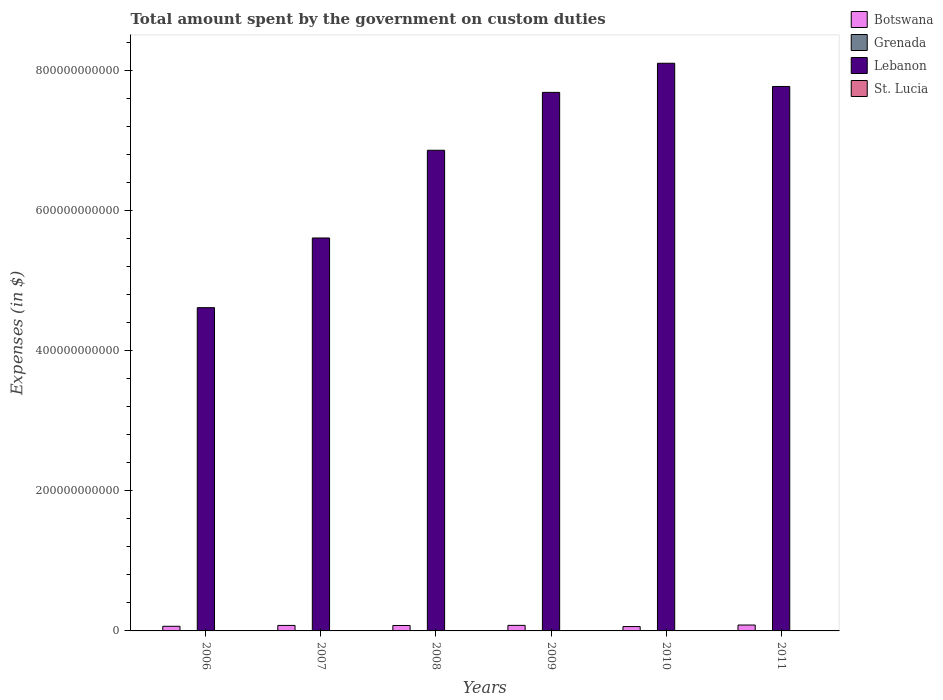How many groups of bars are there?
Your answer should be very brief. 6. Are the number of bars on each tick of the X-axis equal?
Your response must be concise. Yes. In how many cases, is the number of bars for a given year not equal to the number of legend labels?
Your answer should be very brief. 0. What is the amount spent on custom duties by the government in St. Lucia in 2008?
Offer a very short reply. 1.75e+08. Across all years, what is the maximum amount spent on custom duties by the government in Botswana?
Give a very brief answer. 8.42e+09. Across all years, what is the minimum amount spent on custom duties by the government in Botswana?
Your answer should be compact. 6.21e+09. In which year was the amount spent on custom duties by the government in Lebanon maximum?
Provide a short and direct response. 2010. What is the total amount spent on custom duties by the government in Lebanon in the graph?
Your response must be concise. 4.06e+12. What is the difference between the amount spent on custom duties by the government in Lebanon in 2008 and the amount spent on custom duties by the government in St. Lucia in 2009?
Give a very brief answer. 6.86e+11. What is the average amount spent on custom duties by the government in Botswana per year?
Offer a terse response. 7.46e+09. In the year 2009, what is the difference between the amount spent on custom duties by the government in Grenada and amount spent on custom duties by the government in Botswana?
Ensure brevity in your answer.  -7.85e+09. What is the ratio of the amount spent on custom duties by the government in Grenada in 2006 to that in 2010?
Your response must be concise. 1.07. Is the amount spent on custom duties by the government in Lebanon in 2009 less than that in 2010?
Offer a very short reply. Yes. What is the difference between the highest and the second highest amount spent on custom duties by the government in Grenada?
Offer a terse response. 9.00e+06. What is the difference between the highest and the lowest amount spent on custom duties by the government in Lebanon?
Your response must be concise. 3.49e+11. In how many years, is the amount spent on custom duties by the government in Grenada greater than the average amount spent on custom duties by the government in Grenada taken over all years?
Make the answer very short. 2. Is it the case that in every year, the sum of the amount spent on custom duties by the government in Lebanon and amount spent on custom duties by the government in Botswana is greater than the sum of amount spent on custom duties by the government in Grenada and amount spent on custom duties by the government in St. Lucia?
Provide a short and direct response. Yes. What does the 4th bar from the left in 2007 represents?
Give a very brief answer. St. Lucia. What does the 2nd bar from the right in 2011 represents?
Provide a succinct answer. Lebanon. Is it the case that in every year, the sum of the amount spent on custom duties by the government in Grenada and amount spent on custom duties by the government in Botswana is greater than the amount spent on custom duties by the government in St. Lucia?
Your answer should be very brief. Yes. What is the difference between two consecutive major ticks on the Y-axis?
Keep it short and to the point. 2.00e+11. Are the values on the major ticks of Y-axis written in scientific E-notation?
Offer a very short reply. No. Does the graph contain any zero values?
Offer a terse response. No. What is the title of the graph?
Offer a very short reply. Total amount spent by the government on custom duties. Does "Barbados" appear as one of the legend labels in the graph?
Make the answer very short. No. What is the label or title of the X-axis?
Give a very brief answer. Years. What is the label or title of the Y-axis?
Provide a short and direct response. Expenses (in $). What is the Expenses (in $) in Botswana in 2006?
Ensure brevity in your answer.  6.61e+09. What is the Expenses (in $) in Grenada in 2006?
Offer a very short reply. 8.74e+07. What is the Expenses (in $) in Lebanon in 2006?
Give a very brief answer. 4.61e+11. What is the Expenses (in $) of St. Lucia in 2006?
Your answer should be compact. 1.60e+08. What is the Expenses (in $) of Botswana in 2007?
Provide a short and direct response. 7.83e+09. What is the Expenses (in $) in Grenada in 2007?
Provide a succinct answer. 9.11e+07. What is the Expenses (in $) of Lebanon in 2007?
Provide a succinct answer. 5.61e+11. What is the Expenses (in $) in St. Lucia in 2007?
Provide a succinct answer. 1.72e+08. What is the Expenses (in $) in Botswana in 2008?
Offer a very short reply. 7.75e+09. What is the Expenses (in $) in Grenada in 2008?
Offer a very short reply. 1.00e+08. What is the Expenses (in $) in Lebanon in 2008?
Your answer should be very brief. 6.86e+11. What is the Expenses (in $) in St. Lucia in 2008?
Provide a succinct answer. 1.75e+08. What is the Expenses (in $) in Botswana in 2009?
Your answer should be very brief. 7.93e+09. What is the Expenses (in $) in Grenada in 2009?
Ensure brevity in your answer.  7.77e+07. What is the Expenses (in $) of Lebanon in 2009?
Offer a very short reply. 7.68e+11. What is the Expenses (in $) of St. Lucia in 2009?
Provide a short and direct response. 1.55e+08. What is the Expenses (in $) of Botswana in 2010?
Your answer should be very brief. 6.21e+09. What is the Expenses (in $) of Grenada in 2010?
Make the answer very short. 8.15e+07. What is the Expenses (in $) of Lebanon in 2010?
Offer a terse response. 8.10e+11. What is the Expenses (in $) of St. Lucia in 2010?
Give a very brief answer. 1.61e+08. What is the Expenses (in $) of Botswana in 2011?
Give a very brief answer. 8.42e+09. What is the Expenses (in $) of Grenada in 2011?
Provide a succinct answer. 8.71e+07. What is the Expenses (in $) of Lebanon in 2011?
Your response must be concise. 7.77e+11. What is the Expenses (in $) in St. Lucia in 2011?
Offer a very short reply. 1.75e+08. Across all years, what is the maximum Expenses (in $) of Botswana?
Keep it short and to the point. 8.42e+09. Across all years, what is the maximum Expenses (in $) of Grenada?
Offer a terse response. 1.00e+08. Across all years, what is the maximum Expenses (in $) of Lebanon?
Offer a very short reply. 8.10e+11. Across all years, what is the maximum Expenses (in $) in St. Lucia?
Your response must be concise. 1.75e+08. Across all years, what is the minimum Expenses (in $) of Botswana?
Give a very brief answer. 6.21e+09. Across all years, what is the minimum Expenses (in $) in Grenada?
Your answer should be compact. 7.77e+07. Across all years, what is the minimum Expenses (in $) in Lebanon?
Offer a terse response. 4.61e+11. Across all years, what is the minimum Expenses (in $) in St. Lucia?
Make the answer very short. 1.55e+08. What is the total Expenses (in $) in Botswana in the graph?
Keep it short and to the point. 4.48e+1. What is the total Expenses (in $) in Grenada in the graph?
Your answer should be compact. 5.25e+08. What is the total Expenses (in $) in Lebanon in the graph?
Your answer should be compact. 4.06e+12. What is the total Expenses (in $) of St. Lucia in the graph?
Offer a very short reply. 9.98e+08. What is the difference between the Expenses (in $) in Botswana in 2006 and that in 2007?
Give a very brief answer. -1.22e+09. What is the difference between the Expenses (in $) in Grenada in 2006 and that in 2007?
Give a very brief answer. -3.70e+06. What is the difference between the Expenses (in $) in Lebanon in 2006 and that in 2007?
Offer a terse response. -9.94e+1. What is the difference between the Expenses (in $) in St. Lucia in 2006 and that in 2007?
Your answer should be compact. -1.23e+07. What is the difference between the Expenses (in $) in Botswana in 2006 and that in 2008?
Keep it short and to the point. -1.14e+09. What is the difference between the Expenses (in $) of Grenada in 2006 and that in 2008?
Ensure brevity in your answer.  -1.27e+07. What is the difference between the Expenses (in $) in Lebanon in 2006 and that in 2008?
Your response must be concise. -2.25e+11. What is the difference between the Expenses (in $) in St. Lucia in 2006 and that in 2008?
Ensure brevity in your answer.  -1.56e+07. What is the difference between the Expenses (in $) of Botswana in 2006 and that in 2009?
Your response must be concise. -1.32e+09. What is the difference between the Expenses (in $) of Grenada in 2006 and that in 2009?
Provide a succinct answer. 9.70e+06. What is the difference between the Expenses (in $) of Lebanon in 2006 and that in 2009?
Provide a succinct answer. -3.07e+11. What is the difference between the Expenses (in $) in St. Lucia in 2006 and that in 2009?
Your answer should be very brief. 4.90e+06. What is the difference between the Expenses (in $) in Botswana in 2006 and that in 2010?
Ensure brevity in your answer.  4.04e+08. What is the difference between the Expenses (in $) of Grenada in 2006 and that in 2010?
Make the answer very short. 5.90e+06. What is the difference between the Expenses (in $) of Lebanon in 2006 and that in 2010?
Offer a very short reply. -3.49e+11. What is the difference between the Expenses (in $) in St. Lucia in 2006 and that in 2010?
Keep it short and to the point. -1.30e+06. What is the difference between the Expenses (in $) of Botswana in 2006 and that in 2011?
Give a very brief answer. -1.81e+09. What is the difference between the Expenses (in $) in Lebanon in 2006 and that in 2011?
Your response must be concise. -3.16e+11. What is the difference between the Expenses (in $) of St. Lucia in 2006 and that in 2011?
Your answer should be very brief. -1.49e+07. What is the difference between the Expenses (in $) of Botswana in 2007 and that in 2008?
Offer a terse response. 8.47e+07. What is the difference between the Expenses (in $) of Grenada in 2007 and that in 2008?
Offer a terse response. -9.00e+06. What is the difference between the Expenses (in $) in Lebanon in 2007 and that in 2008?
Offer a terse response. -1.25e+11. What is the difference between the Expenses (in $) in St. Lucia in 2007 and that in 2008?
Offer a terse response. -3.30e+06. What is the difference between the Expenses (in $) of Botswana in 2007 and that in 2009?
Your answer should be compact. -9.62e+07. What is the difference between the Expenses (in $) in Grenada in 2007 and that in 2009?
Offer a very short reply. 1.34e+07. What is the difference between the Expenses (in $) in Lebanon in 2007 and that in 2009?
Make the answer very short. -2.08e+11. What is the difference between the Expenses (in $) of St. Lucia in 2007 and that in 2009?
Your answer should be very brief. 1.72e+07. What is the difference between the Expenses (in $) of Botswana in 2007 and that in 2010?
Your answer should be compact. 1.63e+09. What is the difference between the Expenses (in $) in Grenada in 2007 and that in 2010?
Provide a short and direct response. 9.60e+06. What is the difference between the Expenses (in $) of Lebanon in 2007 and that in 2010?
Your response must be concise. -2.49e+11. What is the difference between the Expenses (in $) of St. Lucia in 2007 and that in 2010?
Offer a very short reply. 1.10e+07. What is the difference between the Expenses (in $) of Botswana in 2007 and that in 2011?
Your response must be concise. -5.89e+08. What is the difference between the Expenses (in $) in Grenada in 2007 and that in 2011?
Make the answer very short. 4.00e+06. What is the difference between the Expenses (in $) in Lebanon in 2007 and that in 2011?
Give a very brief answer. -2.16e+11. What is the difference between the Expenses (in $) in St. Lucia in 2007 and that in 2011?
Make the answer very short. -2.60e+06. What is the difference between the Expenses (in $) of Botswana in 2008 and that in 2009?
Ensure brevity in your answer.  -1.81e+08. What is the difference between the Expenses (in $) of Grenada in 2008 and that in 2009?
Offer a terse response. 2.24e+07. What is the difference between the Expenses (in $) in Lebanon in 2008 and that in 2009?
Provide a succinct answer. -8.26e+1. What is the difference between the Expenses (in $) of St. Lucia in 2008 and that in 2009?
Offer a terse response. 2.05e+07. What is the difference between the Expenses (in $) in Botswana in 2008 and that in 2010?
Your answer should be compact. 1.54e+09. What is the difference between the Expenses (in $) in Grenada in 2008 and that in 2010?
Your response must be concise. 1.86e+07. What is the difference between the Expenses (in $) in Lebanon in 2008 and that in 2010?
Keep it short and to the point. -1.24e+11. What is the difference between the Expenses (in $) of St. Lucia in 2008 and that in 2010?
Your response must be concise. 1.43e+07. What is the difference between the Expenses (in $) of Botswana in 2008 and that in 2011?
Keep it short and to the point. -6.74e+08. What is the difference between the Expenses (in $) in Grenada in 2008 and that in 2011?
Your response must be concise. 1.30e+07. What is the difference between the Expenses (in $) of Lebanon in 2008 and that in 2011?
Offer a terse response. -9.10e+1. What is the difference between the Expenses (in $) in St. Lucia in 2008 and that in 2011?
Keep it short and to the point. 7.00e+05. What is the difference between the Expenses (in $) of Botswana in 2009 and that in 2010?
Give a very brief answer. 1.72e+09. What is the difference between the Expenses (in $) in Grenada in 2009 and that in 2010?
Your answer should be compact. -3.80e+06. What is the difference between the Expenses (in $) in Lebanon in 2009 and that in 2010?
Give a very brief answer. -4.15e+1. What is the difference between the Expenses (in $) of St. Lucia in 2009 and that in 2010?
Your answer should be compact. -6.20e+06. What is the difference between the Expenses (in $) in Botswana in 2009 and that in 2011?
Provide a short and direct response. -4.93e+08. What is the difference between the Expenses (in $) of Grenada in 2009 and that in 2011?
Your answer should be very brief. -9.40e+06. What is the difference between the Expenses (in $) of Lebanon in 2009 and that in 2011?
Make the answer very short. -8.39e+09. What is the difference between the Expenses (in $) of St. Lucia in 2009 and that in 2011?
Offer a very short reply. -1.98e+07. What is the difference between the Expenses (in $) in Botswana in 2010 and that in 2011?
Give a very brief answer. -2.22e+09. What is the difference between the Expenses (in $) of Grenada in 2010 and that in 2011?
Ensure brevity in your answer.  -5.60e+06. What is the difference between the Expenses (in $) in Lebanon in 2010 and that in 2011?
Provide a succinct answer. 3.31e+1. What is the difference between the Expenses (in $) in St. Lucia in 2010 and that in 2011?
Ensure brevity in your answer.  -1.36e+07. What is the difference between the Expenses (in $) in Botswana in 2006 and the Expenses (in $) in Grenada in 2007?
Your answer should be compact. 6.52e+09. What is the difference between the Expenses (in $) of Botswana in 2006 and the Expenses (in $) of Lebanon in 2007?
Provide a short and direct response. -5.54e+11. What is the difference between the Expenses (in $) of Botswana in 2006 and the Expenses (in $) of St. Lucia in 2007?
Your answer should be compact. 6.44e+09. What is the difference between the Expenses (in $) in Grenada in 2006 and the Expenses (in $) in Lebanon in 2007?
Your answer should be compact. -5.60e+11. What is the difference between the Expenses (in $) in Grenada in 2006 and the Expenses (in $) in St. Lucia in 2007?
Keep it short and to the point. -8.47e+07. What is the difference between the Expenses (in $) of Lebanon in 2006 and the Expenses (in $) of St. Lucia in 2007?
Ensure brevity in your answer.  4.61e+11. What is the difference between the Expenses (in $) in Botswana in 2006 and the Expenses (in $) in Grenada in 2008?
Your answer should be very brief. 6.51e+09. What is the difference between the Expenses (in $) of Botswana in 2006 and the Expenses (in $) of Lebanon in 2008?
Give a very brief answer. -6.79e+11. What is the difference between the Expenses (in $) in Botswana in 2006 and the Expenses (in $) in St. Lucia in 2008?
Ensure brevity in your answer.  6.44e+09. What is the difference between the Expenses (in $) of Grenada in 2006 and the Expenses (in $) of Lebanon in 2008?
Keep it short and to the point. -6.86e+11. What is the difference between the Expenses (in $) of Grenada in 2006 and the Expenses (in $) of St. Lucia in 2008?
Offer a terse response. -8.80e+07. What is the difference between the Expenses (in $) in Lebanon in 2006 and the Expenses (in $) in St. Lucia in 2008?
Your answer should be very brief. 4.61e+11. What is the difference between the Expenses (in $) of Botswana in 2006 and the Expenses (in $) of Grenada in 2009?
Give a very brief answer. 6.53e+09. What is the difference between the Expenses (in $) in Botswana in 2006 and the Expenses (in $) in Lebanon in 2009?
Your answer should be very brief. -7.62e+11. What is the difference between the Expenses (in $) of Botswana in 2006 and the Expenses (in $) of St. Lucia in 2009?
Provide a short and direct response. 6.46e+09. What is the difference between the Expenses (in $) in Grenada in 2006 and the Expenses (in $) in Lebanon in 2009?
Offer a very short reply. -7.68e+11. What is the difference between the Expenses (in $) of Grenada in 2006 and the Expenses (in $) of St. Lucia in 2009?
Give a very brief answer. -6.75e+07. What is the difference between the Expenses (in $) in Lebanon in 2006 and the Expenses (in $) in St. Lucia in 2009?
Offer a very short reply. 4.61e+11. What is the difference between the Expenses (in $) of Botswana in 2006 and the Expenses (in $) of Grenada in 2010?
Your answer should be compact. 6.53e+09. What is the difference between the Expenses (in $) in Botswana in 2006 and the Expenses (in $) in Lebanon in 2010?
Give a very brief answer. -8.03e+11. What is the difference between the Expenses (in $) in Botswana in 2006 and the Expenses (in $) in St. Lucia in 2010?
Your response must be concise. 6.45e+09. What is the difference between the Expenses (in $) of Grenada in 2006 and the Expenses (in $) of Lebanon in 2010?
Your answer should be very brief. -8.10e+11. What is the difference between the Expenses (in $) of Grenada in 2006 and the Expenses (in $) of St. Lucia in 2010?
Your answer should be compact. -7.37e+07. What is the difference between the Expenses (in $) of Lebanon in 2006 and the Expenses (in $) of St. Lucia in 2010?
Give a very brief answer. 4.61e+11. What is the difference between the Expenses (in $) of Botswana in 2006 and the Expenses (in $) of Grenada in 2011?
Your response must be concise. 6.52e+09. What is the difference between the Expenses (in $) in Botswana in 2006 and the Expenses (in $) in Lebanon in 2011?
Make the answer very short. -7.70e+11. What is the difference between the Expenses (in $) in Botswana in 2006 and the Expenses (in $) in St. Lucia in 2011?
Provide a short and direct response. 6.44e+09. What is the difference between the Expenses (in $) in Grenada in 2006 and the Expenses (in $) in Lebanon in 2011?
Your answer should be compact. -7.77e+11. What is the difference between the Expenses (in $) in Grenada in 2006 and the Expenses (in $) in St. Lucia in 2011?
Your response must be concise. -8.73e+07. What is the difference between the Expenses (in $) of Lebanon in 2006 and the Expenses (in $) of St. Lucia in 2011?
Give a very brief answer. 4.61e+11. What is the difference between the Expenses (in $) in Botswana in 2007 and the Expenses (in $) in Grenada in 2008?
Provide a short and direct response. 7.73e+09. What is the difference between the Expenses (in $) of Botswana in 2007 and the Expenses (in $) of Lebanon in 2008?
Give a very brief answer. -6.78e+11. What is the difference between the Expenses (in $) in Botswana in 2007 and the Expenses (in $) in St. Lucia in 2008?
Provide a short and direct response. 7.66e+09. What is the difference between the Expenses (in $) of Grenada in 2007 and the Expenses (in $) of Lebanon in 2008?
Your answer should be very brief. -6.86e+11. What is the difference between the Expenses (in $) in Grenada in 2007 and the Expenses (in $) in St. Lucia in 2008?
Offer a very short reply. -8.43e+07. What is the difference between the Expenses (in $) of Lebanon in 2007 and the Expenses (in $) of St. Lucia in 2008?
Your response must be concise. 5.60e+11. What is the difference between the Expenses (in $) of Botswana in 2007 and the Expenses (in $) of Grenada in 2009?
Ensure brevity in your answer.  7.76e+09. What is the difference between the Expenses (in $) of Botswana in 2007 and the Expenses (in $) of Lebanon in 2009?
Offer a terse response. -7.60e+11. What is the difference between the Expenses (in $) of Botswana in 2007 and the Expenses (in $) of St. Lucia in 2009?
Ensure brevity in your answer.  7.68e+09. What is the difference between the Expenses (in $) in Grenada in 2007 and the Expenses (in $) in Lebanon in 2009?
Offer a very short reply. -7.68e+11. What is the difference between the Expenses (in $) in Grenada in 2007 and the Expenses (in $) in St. Lucia in 2009?
Offer a terse response. -6.38e+07. What is the difference between the Expenses (in $) of Lebanon in 2007 and the Expenses (in $) of St. Lucia in 2009?
Ensure brevity in your answer.  5.60e+11. What is the difference between the Expenses (in $) of Botswana in 2007 and the Expenses (in $) of Grenada in 2010?
Ensure brevity in your answer.  7.75e+09. What is the difference between the Expenses (in $) of Botswana in 2007 and the Expenses (in $) of Lebanon in 2010?
Your answer should be compact. -8.02e+11. What is the difference between the Expenses (in $) in Botswana in 2007 and the Expenses (in $) in St. Lucia in 2010?
Your answer should be compact. 7.67e+09. What is the difference between the Expenses (in $) of Grenada in 2007 and the Expenses (in $) of Lebanon in 2010?
Your answer should be compact. -8.10e+11. What is the difference between the Expenses (in $) in Grenada in 2007 and the Expenses (in $) in St. Lucia in 2010?
Give a very brief answer. -7.00e+07. What is the difference between the Expenses (in $) of Lebanon in 2007 and the Expenses (in $) of St. Lucia in 2010?
Your response must be concise. 5.60e+11. What is the difference between the Expenses (in $) of Botswana in 2007 and the Expenses (in $) of Grenada in 2011?
Provide a succinct answer. 7.75e+09. What is the difference between the Expenses (in $) of Botswana in 2007 and the Expenses (in $) of Lebanon in 2011?
Ensure brevity in your answer.  -7.69e+11. What is the difference between the Expenses (in $) of Botswana in 2007 and the Expenses (in $) of St. Lucia in 2011?
Your answer should be compact. 7.66e+09. What is the difference between the Expenses (in $) in Grenada in 2007 and the Expenses (in $) in Lebanon in 2011?
Provide a succinct answer. -7.77e+11. What is the difference between the Expenses (in $) in Grenada in 2007 and the Expenses (in $) in St. Lucia in 2011?
Provide a short and direct response. -8.36e+07. What is the difference between the Expenses (in $) of Lebanon in 2007 and the Expenses (in $) of St. Lucia in 2011?
Your answer should be very brief. 5.60e+11. What is the difference between the Expenses (in $) of Botswana in 2008 and the Expenses (in $) of Grenada in 2009?
Offer a terse response. 7.67e+09. What is the difference between the Expenses (in $) of Botswana in 2008 and the Expenses (in $) of Lebanon in 2009?
Your answer should be very brief. -7.60e+11. What is the difference between the Expenses (in $) of Botswana in 2008 and the Expenses (in $) of St. Lucia in 2009?
Offer a very short reply. 7.60e+09. What is the difference between the Expenses (in $) in Grenada in 2008 and the Expenses (in $) in Lebanon in 2009?
Offer a very short reply. -7.68e+11. What is the difference between the Expenses (in $) of Grenada in 2008 and the Expenses (in $) of St. Lucia in 2009?
Give a very brief answer. -5.48e+07. What is the difference between the Expenses (in $) of Lebanon in 2008 and the Expenses (in $) of St. Lucia in 2009?
Your response must be concise. 6.86e+11. What is the difference between the Expenses (in $) in Botswana in 2008 and the Expenses (in $) in Grenada in 2010?
Give a very brief answer. 7.67e+09. What is the difference between the Expenses (in $) of Botswana in 2008 and the Expenses (in $) of Lebanon in 2010?
Offer a terse response. -8.02e+11. What is the difference between the Expenses (in $) in Botswana in 2008 and the Expenses (in $) in St. Lucia in 2010?
Give a very brief answer. 7.59e+09. What is the difference between the Expenses (in $) in Grenada in 2008 and the Expenses (in $) in Lebanon in 2010?
Make the answer very short. -8.10e+11. What is the difference between the Expenses (in $) in Grenada in 2008 and the Expenses (in $) in St. Lucia in 2010?
Offer a very short reply. -6.10e+07. What is the difference between the Expenses (in $) in Lebanon in 2008 and the Expenses (in $) in St. Lucia in 2010?
Make the answer very short. 6.86e+11. What is the difference between the Expenses (in $) of Botswana in 2008 and the Expenses (in $) of Grenada in 2011?
Offer a very short reply. 7.66e+09. What is the difference between the Expenses (in $) of Botswana in 2008 and the Expenses (in $) of Lebanon in 2011?
Ensure brevity in your answer.  -7.69e+11. What is the difference between the Expenses (in $) of Botswana in 2008 and the Expenses (in $) of St. Lucia in 2011?
Ensure brevity in your answer.  7.58e+09. What is the difference between the Expenses (in $) in Grenada in 2008 and the Expenses (in $) in Lebanon in 2011?
Give a very brief answer. -7.77e+11. What is the difference between the Expenses (in $) of Grenada in 2008 and the Expenses (in $) of St. Lucia in 2011?
Provide a short and direct response. -7.46e+07. What is the difference between the Expenses (in $) of Lebanon in 2008 and the Expenses (in $) of St. Lucia in 2011?
Provide a succinct answer. 6.85e+11. What is the difference between the Expenses (in $) in Botswana in 2009 and the Expenses (in $) in Grenada in 2010?
Keep it short and to the point. 7.85e+09. What is the difference between the Expenses (in $) in Botswana in 2009 and the Expenses (in $) in Lebanon in 2010?
Make the answer very short. -8.02e+11. What is the difference between the Expenses (in $) of Botswana in 2009 and the Expenses (in $) of St. Lucia in 2010?
Ensure brevity in your answer.  7.77e+09. What is the difference between the Expenses (in $) of Grenada in 2009 and the Expenses (in $) of Lebanon in 2010?
Your answer should be compact. -8.10e+11. What is the difference between the Expenses (in $) in Grenada in 2009 and the Expenses (in $) in St. Lucia in 2010?
Provide a short and direct response. -8.34e+07. What is the difference between the Expenses (in $) in Lebanon in 2009 and the Expenses (in $) in St. Lucia in 2010?
Offer a very short reply. 7.68e+11. What is the difference between the Expenses (in $) in Botswana in 2009 and the Expenses (in $) in Grenada in 2011?
Make the answer very short. 7.84e+09. What is the difference between the Expenses (in $) of Botswana in 2009 and the Expenses (in $) of Lebanon in 2011?
Give a very brief answer. -7.69e+11. What is the difference between the Expenses (in $) in Botswana in 2009 and the Expenses (in $) in St. Lucia in 2011?
Offer a very short reply. 7.76e+09. What is the difference between the Expenses (in $) of Grenada in 2009 and the Expenses (in $) of Lebanon in 2011?
Your answer should be compact. -7.77e+11. What is the difference between the Expenses (in $) in Grenada in 2009 and the Expenses (in $) in St. Lucia in 2011?
Ensure brevity in your answer.  -9.70e+07. What is the difference between the Expenses (in $) of Lebanon in 2009 and the Expenses (in $) of St. Lucia in 2011?
Ensure brevity in your answer.  7.68e+11. What is the difference between the Expenses (in $) of Botswana in 2010 and the Expenses (in $) of Grenada in 2011?
Give a very brief answer. 6.12e+09. What is the difference between the Expenses (in $) of Botswana in 2010 and the Expenses (in $) of Lebanon in 2011?
Keep it short and to the point. -7.70e+11. What is the difference between the Expenses (in $) of Botswana in 2010 and the Expenses (in $) of St. Lucia in 2011?
Make the answer very short. 6.03e+09. What is the difference between the Expenses (in $) in Grenada in 2010 and the Expenses (in $) in Lebanon in 2011?
Offer a very short reply. -7.77e+11. What is the difference between the Expenses (in $) of Grenada in 2010 and the Expenses (in $) of St. Lucia in 2011?
Make the answer very short. -9.32e+07. What is the difference between the Expenses (in $) of Lebanon in 2010 and the Expenses (in $) of St. Lucia in 2011?
Provide a short and direct response. 8.10e+11. What is the average Expenses (in $) of Botswana per year?
Make the answer very short. 7.46e+09. What is the average Expenses (in $) of Grenada per year?
Offer a terse response. 8.75e+07. What is the average Expenses (in $) in Lebanon per year?
Keep it short and to the point. 6.77e+11. What is the average Expenses (in $) of St. Lucia per year?
Offer a terse response. 1.66e+08. In the year 2006, what is the difference between the Expenses (in $) in Botswana and Expenses (in $) in Grenada?
Offer a very short reply. 6.52e+09. In the year 2006, what is the difference between the Expenses (in $) of Botswana and Expenses (in $) of Lebanon?
Your answer should be very brief. -4.55e+11. In the year 2006, what is the difference between the Expenses (in $) of Botswana and Expenses (in $) of St. Lucia?
Keep it short and to the point. 6.45e+09. In the year 2006, what is the difference between the Expenses (in $) of Grenada and Expenses (in $) of Lebanon?
Your answer should be very brief. -4.61e+11. In the year 2006, what is the difference between the Expenses (in $) in Grenada and Expenses (in $) in St. Lucia?
Make the answer very short. -7.24e+07. In the year 2006, what is the difference between the Expenses (in $) in Lebanon and Expenses (in $) in St. Lucia?
Offer a very short reply. 4.61e+11. In the year 2007, what is the difference between the Expenses (in $) in Botswana and Expenses (in $) in Grenada?
Your answer should be very brief. 7.74e+09. In the year 2007, what is the difference between the Expenses (in $) in Botswana and Expenses (in $) in Lebanon?
Provide a short and direct response. -5.53e+11. In the year 2007, what is the difference between the Expenses (in $) of Botswana and Expenses (in $) of St. Lucia?
Your answer should be very brief. 7.66e+09. In the year 2007, what is the difference between the Expenses (in $) in Grenada and Expenses (in $) in Lebanon?
Offer a terse response. -5.60e+11. In the year 2007, what is the difference between the Expenses (in $) in Grenada and Expenses (in $) in St. Lucia?
Provide a succinct answer. -8.10e+07. In the year 2007, what is the difference between the Expenses (in $) of Lebanon and Expenses (in $) of St. Lucia?
Provide a succinct answer. 5.60e+11. In the year 2008, what is the difference between the Expenses (in $) of Botswana and Expenses (in $) of Grenada?
Offer a very short reply. 7.65e+09. In the year 2008, what is the difference between the Expenses (in $) of Botswana and Expenses (in $) of Lebanon?
Provide a succinct answer. -6.78e+11. In the year 2008, what is the difference between the Expenses (in $) of Botswana and Expenses (in $) of St. Lucia?
Give a very brief answer. 7.57e+09. In the year 2008, what is the difference between the Expenses (in $) in Grenada and Expenses (in $) in Lebanon?
Offer a very short reply. -6.86e+11. In the year 2008, what is the difference between the Expenses (in $) of Grenada and Expenses (in $) of St. Lucia?
Provide a succinct answer. -7.53e+07. In the year 2008, what is the difference between the Expenses (in $) in Lebanon and Expenses (in $) in St. Lucia?
Offer a terse response. 6.85e+11. In the year 2009, what is the difference between the Expenses (in $) in Botswana and Expenses (in $) in Grenada?
Provide a succinct answer. 7.85e+09. In the year 2009, what is the difference between the Expenses (in $) of Botswana and Expenses (in $) of Lebanon?
Ensure brevity in your answer.  -7.60e+11. In the year 2009, what is the difference between the Expenses (in $) of Botswana and Expenses (in $) of St. Lucia?
Your response must be concise. 7.78e+09. In the year 2009, what is the difference between the Expenses (in $) of Grenada and Expenses (in $) of Lebanon?
Give a very brief answer. -7.68e+11. In the year 2009, what is the difference between the Expenses (in $) in Grenada and Expenses (in $) in St. Lucia?
Your answer should be compact. -7.72e+07. In the year 2009, what is the difference between the Expenses (in $) of Lebanon and Expenses (in $) of St. Lucia?
Provide a succinct answer. 7.68e+11. In the year 2010, what is the difference between the Expenses (in $) in Botswana and Expenses (in $) in Grenada?
Keep it short and to the point. 6.13e+09. In the year 2010, what is the difference between the Expenses (in $) of Botswana and Expenses (in $) of Lebanon?
Your response must be concise. -8.04e+11. In the year 2010, what is the difference between the Expenses (in $) of Botswana and Expenses (in $) of St. Lucia?
Your answer should be compact. 6.05e+09. In the year 2010, what is the difference between the Expenses (in $) in Grenada and Expenses (in $) in Lebanon?
Your response must be concise. -8.10e+11. In the year 2010, what is the difference between the Expenses (in $) of Grenada and Expenses (in $) of St. Lucia?
Provide a short and direct response. -7.96e+07. In the year 2010, what is the difference between the Expenses (in $) of Lebanon and Expenses (in $) of St. Lucia?
Provide a short and direct response. 8.10e+11. In the year 2011, what is the difference between the Expenses (in $) in Botswana and Expenses (in $) in Grenada?
Offer a terse response. 8.34e+09. In the year 2011, what is the difference between the Expenses (in $) in Botswana and Expenses (in $) in Lebanon?
Your answer should be very brief. -7.68e+11. In the year 2011, what is the difference between the Expenses (in $) of Botswana and Expenses (in $) of St. Lucia?
Provide a succinct answer. 8.25e+09. In the year 2011, what is the difference between the Expenses (in $) in Grenada and Expenses (in $) in Lebanon?
Your response must be concise. -7.77e+11. In the year 2011, what is the difference between the Expenses (in $) of Grenada and Expenses (in $) of St. Lucia?
Offer a very short reply. -8.76e+07. In the year 2011, what is the difference between the Expenses (in $) in Lebanon and Expenses (in $) in St. Lucia?
Your answer should be very brief. 7.76e+11. What is the ratio of the Expenses (in $) in Botswana in 2006 to that in 2007?
Your answer should be very brief. 0.84. What is the ratio of the Expenses (in $) of Grenada in 2006 to that in 2007?
Your response must be concise. 0.96. What is the ratio of the Expenses (in $) of Lebanon in 2006 to that in 2007?
Your answer should be very brief. 0.82. What is the ratio of the Expenses (in $) of St. Lucia in 2006 to that in 2007?
Provide a succinct answer. 0.93. What is the ratio of the Expenses (in $) in Botswana in 2006 to that in 2008?
Your response must be concise. 0.85. What is the ratio of the Expenses (in $) of Grenada in 2006 to that in 2008?
Ensure brevity in your answer.  0.87. What is the ratio of the Expenses (in $) in Lebanon in 2006 to that in 2008?
Offer a terse response. 0.67. What is the ratio of the Expenses (in $) in St. Lucia in 2006 to that in 2008?
Offer a very short reply. 0.91. What is the ratio of the Expenses (in $) in Botswana in 2006 to that in 2009?
Your answer should be very brief. 0.83. What is the ratio of the Expenses (in $) of Grenada in 2006 to that in 2009?
Your response must be concise. 1.12. What is the ratio of the Expenses (in $) of Lebanon in 2006 to that in 2009?
Ensure brevity in your answer.  0.6. What is the ratio of the Expenses (in $) of St. Lucia in 2006 to that in 2009?
Provide a short and direct response. 1.03. What is the ratio of the Expenses (in $) of Botswana in 2006 to that in 2010?
Ensure brevity in your answer.  1.07. What is the ratio of the Expenses (in $) of Grenada in 2006 to that in 2010?
Ensure brevity in your answer.  1.07. What is the ratio of the Expenses (in $) in Lebanon in 2006 to that in 2010?
Ensure brevity in your answer.  0.57. What is the ratio of the Expenses (in $) in Botswana in 2006 to that in 2011?
Provide a short and direct response. 0.78. What is the ratio of the Expenses (in $) in Grenada in 2006 to that in 2011?
Provide a short and direct response. 1. What is the ratio of the Expenses (in $) of Lebanon in 2006 to that in 2011?
Offer a very short reply. 0.59. What is the ratio of the Expenses (in $) in St. Lucia in 2006 to that in 2011?
Make the answer very short. 0.91. What is the ratio of the Expenses (in $) in Botswana in 2007 to that in 2008?
Keep it short and to the point. 1.01. What is the ratio of the Expenses (in $) of Grenada in 2007 to that in 2008?
Your response must be concise. 0.91. What is the ratio of the Expenses (in $) in Lebanon in 2007 to that in 2008?
Offer a very short reply. 0.82. What is the ratio of the Expenses (in $) of St. Lucia in 2007 to that in 2008?
Your answer should be very brief. 0.98. What is the ratio of the Expenses (in $) in Botswana in 2007 to that in 2009?
Ensure brevity in your answer.  0.99. What is the ratio of the Expenses (in $) of Grenada in 2007 to that in 2009?
Your answer should be very brief. 1.17. What is the ratio of the Expenses (in $) in Lebanon in 2007 to that in 2009?
Keep it short and to the point. 0.73. What is the ratio of the Expenses (in $) in St. Lucia in 2007 to that in 2009?
Give a very brief answer. 1.11. What is the ratio of the Expenses (in $) of Botswana in 2007 to that in 2010?
Your answer should be compact. 1.26. What is the ratio of the Expenses (in $) in Grenada in 2007 to that in 2010?
Make the answer very short. 1.12. What is the ratio of the Expenses (in $) in Lebanon in 2007 to that in 2010?
Your answer should be very brief. 0.69. What is the ratio of the Expenses (in $) of St. Lucia in 2007 to that in 2010?
Make the answer very short. 1.07. What is the ratio of the Expenses (in $) in Grenada in 2007 to that in 2011?
Make the answer very short. 1.05. What is the ratio of the Expenses (in $) of Lebanon in 2007 to that in 2011?
Ensure brevity in your answer.  0.72. What is the ratio of the Expenses (in $) in St. Lucia in 2007 to that in 2011?
Provide a short and direct response. 0.99. What is the ratio of the Expenses (in $) in Botswana in 2008 to that in 2009?
Offer a terse response. 0.98. What is the ratio of the Expenses (in $) of Grenada in 2008 to that in 2009?
Your answer should be very brief. 1.29. What is the ratio of the Expenses (in $) in Lebanon in 2008 to that in 2009?
Ensure brevity in your answer.  0.89. What is the ratio of the Expenses (in $) in St. Lucia in 2008 to that in 2009?
Give a very brief answer. 1.13. What is the ratio of the Expenses (in $) of Botswana in 2008 to that in 2010?
Make the answer very short. 1.25. What is the ratio of the Expenses (in $) in Grenada in 2008 to that in 2010?
Make the answer very short. 1.23. What is the ratio of the Expenses (in $) in Lebanon in 2008 to that in 2010?
Offer a terse response. 0.85. What is the ratio of the Expenses (in $) in St. Lucia in 2008 to that in 2010?
Keep it short and to the point. 1.09. What is the ratio of the Expenses (in $) of Grenada in 2008 to that in 2011?
Your answer should be very brief. 1.15. What is the ratio of the Expenses (in $) in Lebanon in 2008 to that in 2011?
Offer a very short reply. 0.88. What is the ratio of the Expenses (in $) of Botswana in 2009 to that in 2010?
Offer a terse response. 1.28. What is the ratio of the Expenses (in $) of Grenada in 2009 to that in 2010?
Provide a succinct answer. 0.95. What is the ratio of the Expenses (in $) in Lebanon in 2009 to that in 2010?
Your answer should be very brief. 0.95. What is the ratio of the Expenses (in $) in St. Lucia in 2009 to that in 2010?
Your response must be concise. 0.96. What is the ratio of the Expenses (in $) in Botswana in 2009 to that in 2011?
Make the answer very short. 0.94. What is the ratio of the Expenses (in $) in Grenada in 2009 to that in 2011?
Give a very brief answer. 0.89. What is the ratio of the Expenses (in $) in Lebanon in 2009 to that in 2011?
Your answer should be compact. 0.99. What is the ratio of the Expenses (in $) in St. Lucia in 2009 to that in 2011?
Provide a short and direct response. 0.89. What is the ratio of the Expenses (in $) of Botswana in 2010 to that in 2011?
Ensure brevity in your answer.  0.74. What is the ratio of the Expenses (in $) of Grenada in 2010 to that in 2011?
Give a very brief answer. 0.94. What is the ratio of the Expenses (in $) in Lebanon in 2010 to that in 2011?
Your answer should be very brief. 1.04. What is the ratio of the Expenses (in $) in St. Lucia in 2010 to that in 2011?
Make the answer very short. 0.92. What is the difference between the highest and the second highest Expenses (in $) of Botswana?
Offer a terse response. 4.93e+08. What is the difference between the highest and the second highest Expenses (in $) of Grenada?
Offer a very short reply. 9.00e+06. What is the difference between the highest and the second highest Expenses (in $) in Lebanon?
Make the answer very short. 3.31e+1. What is the difference between the highest and the second highest Expenses (in $) of St. Lucia?
Provide a short and direct response. 7.00e+05. What is the difference between the highest and the lowest Expenses (in $) in Botswana?
Offer a terse response. 2.22e+09. What is the difference between the highest and the lowest Expenses (in $) in Grenada?
Your answer should be very brief. 2.24e+07. What is the difference between the highest and the lowest Expenses (in $) of Lebanon?
Your answer should be compact. 3.49e+11. What is the difference between the highest and the lowest Expenses (in $) in St. Lucia?
Your answer should be compact. 2.05e+07. 